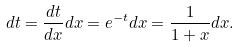<formula> <loc_0><loc_0><loc_500><loc_500>d t = \frac { d t } { d x } d x = e ^ { - t } d x = \frac { 1 } { 1 + x } d x .</formula> 